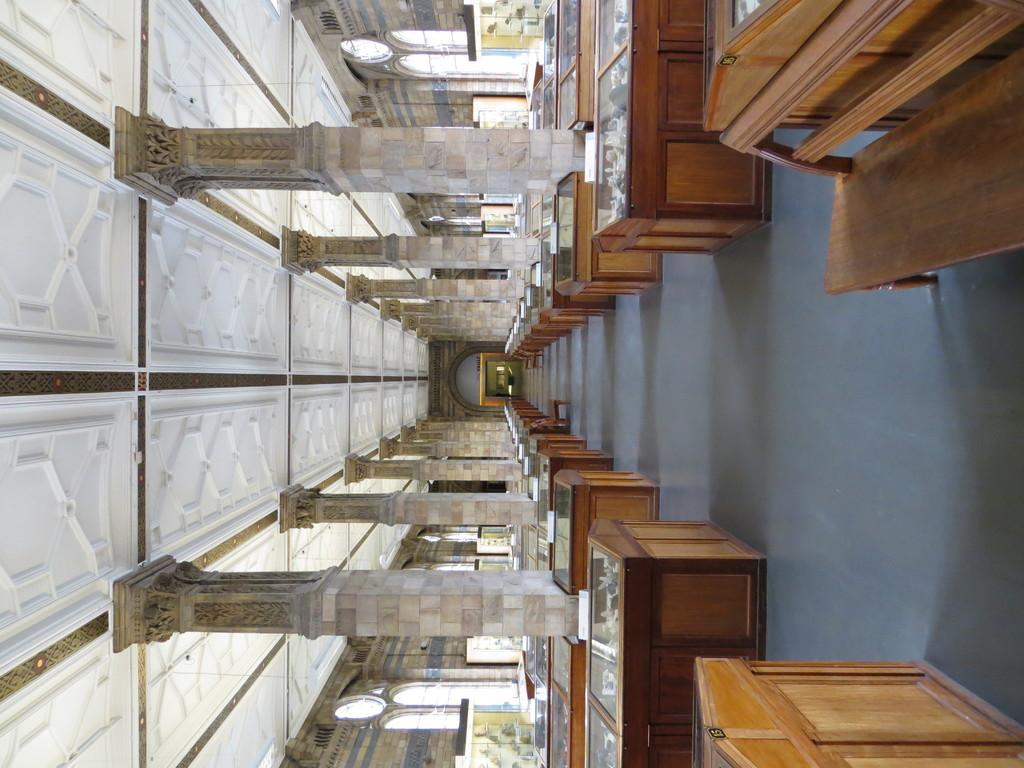What is the main structure in the center of the image? There is a building in the center of the image. What are some features of the building? The building has a wall and a roof. What type of outdoor furniture is present in the image? There is a bench and tables in the image. What is placed on the tables? The tables have objects on them. What architectural elements can be seen in the image? There are pillars in the image. What type of songs can be heard playing in the background of the image? There is no audio or indication of music in the image, so it is not possible to determine what songs might be heard. --- Facts: 1. There is a person sitting on a chair in the image. 2. The person is holding a book. 3. The book has a cover. 4. The chair has a backrest. 5. The chair has armrests. 6. There is a table next to the chair. Absurd Topics: dance, ocean, fireworks Conversation: What is the person in the image doing? The person is sitting on a chair in the image. What is the person holding while sitting on the chair? The person is holding a book. What can be seen on the book? The book has a cover. What type of chair is the person sitting on? The chair has a backrest and armrests. What furniture is located next to the chair? There is a table next to the chair. Reasoning: Let's think step by step in order to produce the conversation. We start by identifying the main subject of the image, which is the person sitting on a chair. Then, we describe what the person is holding, which is a book. Next, we mention specific details about the book, such as its cover. We then describe the chair, noting its backrest and armrests. Finally, we acknowledge the presence of a table next to the chair. Absurd Question/Answer: What type of dance can be seen in the image? There is no dance or indication of dancing in the image, so it is not possible to determine what type of dance might be seen. 